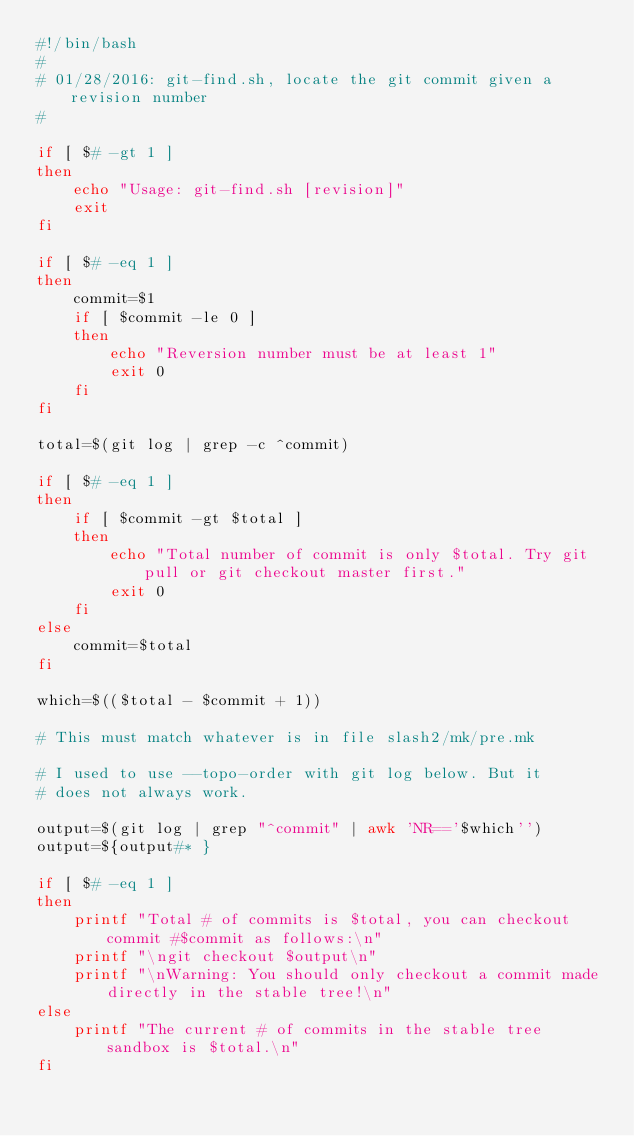<code> <loc_0><loc_0><loc_500><loc_500><_Bash_>#!/bin/bash
#
# 01/28/2016: git-find.sh, locate the git commit given a revision number
#

if [ $# -gt 1 ]
then
    echo "Usage: git-find.sh [revision]"
    exit
fi

if [ $# -eq 1 ]
then
    commit=$1
    if [ $commit -le 0 ]
    then
        echo "Reversion number must be at least 1"
        exit 0
    fi
fi

total=$(git log | grep -c ^commit)

if [ $# -eq 1 ]
then
    if [ $commit -gt $total ]
    then
        echo "Total number of commit is only $total. Try git pull or git checkout master first."
        exit 0
    fi
else
    commit=$total
fi

which=$(($total - $commit + 1))

# This must match whatever is in file slash2/mk/pre.mk

# I used to use --topo-order with git log below. But it
# does not always work.

output=$(git log | grep "^commit" | awk 'NR=='$which'')
output=${output#* }

if [ $# -eq 1 ]
then
    printf "Total # of commits is $total, you can checkout commit #$commit as follows:\n"
    printf "\ngit checkout $output\n"
    printf "\nWarning: You should only checkout a commit made directly in the stable tree!\n"
else
    printf "The current # of commits in the stable tree sandbox is $total.\n"
fi
</code> 